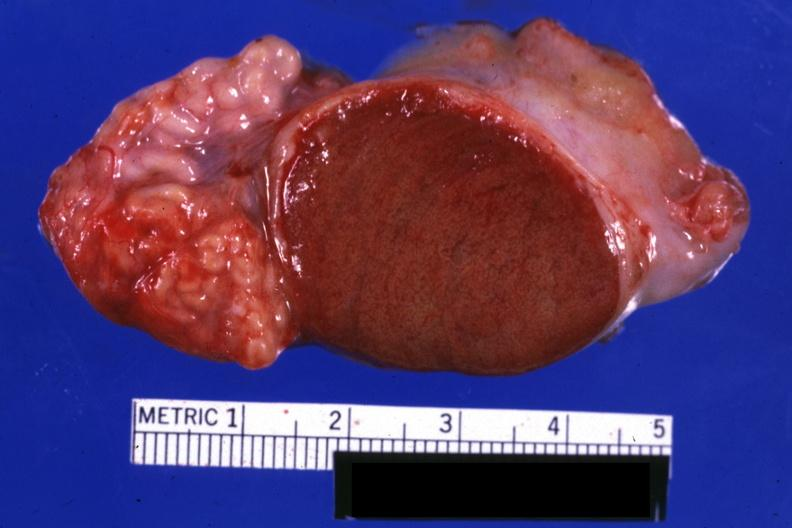how is excellent close-up view sliced testicle with intact epididymis?
Answer the question using a single word or phrase. Open 